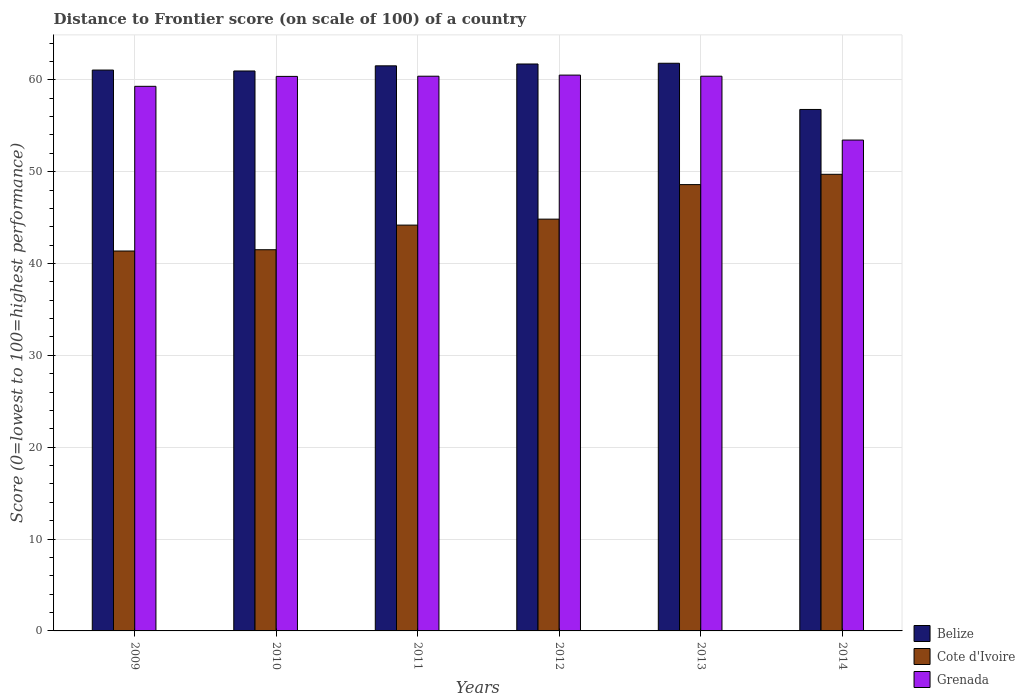How many different coloured bars are there?
Provide a succinct answer. 3. How many groups of bars are there?
Ensure brevity in your answer.  6. How many bars are there on the 3rd tick from the left?
Your answer should be compact. 3. What is the label of the 1st group of bars from the left?
Your answer should be very brief. 2009. In how many cases, is the number of bars for a given year not equal to the number of legend labels?
Provide a succinct answer. 0. What is the distance to frontier score of in Cote d'Ivoire in 2009?
Your answer should be very brief. 41.36. Across all years, what is the maximum distance to frontier score of in Belize?
Offer a very short reply. 61.8. Across all years, what is the minimum distance to frontier score of in Belize?
Your response must be concise. 56.77. In which year was the distance to frontier score of in Grenada maximum?
Your answer should be compact. 2012. In which year was the distance to frontier score of in Grenada minimum?
Give a very brief answer. 2014. What is the total distance to frontier score of in Cote d'Ivoire in the graph?
Your answer should be very brief. 270.17. What is the difference between the distance to frontier score of in Belize in 2012 and that in 2013?
Your response must be concise. -0.08. What is the difference between the distance to frontier score of in Grenada in 2014 and the distance to frontier score of in Belize in 2012?
Keep it short and to the point. -8.28. What is the average distance to frontier score of in Cote d'Ivoire per year?
Your response must be concise. 45.03. In the year 2012, what is the difference between the distance to frontier score of in Belize and distance to frontier score of in Cote d'Ivoire?
Ensure brevity in your answer.  16.89. What is the ratio of the distance to frontier score of in Cote d'Ivoire in 2009 to that in 2013?
Offer a very short reply. 0.85. Is the difference between the distance to frontier score of in Belize in 2011 and 2013 greater than the difference between the distance to frontier score of in Cote d'Ivoire in 2011 and 2013?
Ensure brevity in your answer.  Yes. What is the difference between the highest and the second highest distance to frontier score of in Belize?
Make the answer very short. 0.08. What is the difference between the highest and the lowest distance to frontier score of in Cote d'Ivoire?
Keep it short and to the point. 8.35. Is the sum of the distance to frontier score of in Cote d'Ivoire in 2012 and 2014 greater than the maximum distance to frontier score of in Grenada across all years?
Provide a succinct answer. Yes. What does the 3rd bar from the left in 2013 represents?
Your answer should be compact. Grenada. What does the 1st bar from the right in 2013 represents?
Your answer should be very brief. Grenada. Is it the case that in every year, the sum of the distance to frontier score of in Belize and distance to frontier score of in Cote d'Ivoire is greater than the distance to frontier score of in Grenada?
Make the answer very short. Yes. How many years are there in the graph?
Provide a succinct answer. 6. What is the difference between two consecutive major ticks on the Y-axis?
Provide a succinct answer. 10. Does the graph contain any zero values?
Your response must be concise. No. How many legend labels are there?
Keep it short and to the point. 3. What is the title of the graph?
Make the answer very short. Distance to Frontier score (on scale of 100) of a country. What is the label or title of the Y-axis?
Your answer should be compact. Score (0=lowest to 100=highest performance). What is the Score (0=lowest to 100=highest performance) of Belize in 2009?
Make the answer very short. 61.06. What is the Score (0=lowest to 100=highest performance) of Cote d'Ivoire in 2009?
Ensure brevity in your answer.  41.36. What is the Score (0=lowest to 100=highest performance) of Grenada in 2009?
Provide a short and direct response. 59.29. What is the Score (0=lowest to 100=highest performance) of Belize in 2010?
Offer a terse response. 60.96. What is the Score (0=lowest to 100=highest performance) in Cote d'Ivoire in 2010?
Provide a short and direct response. 41.5. What is the Score (0=lowest to 100=highest performance) in Grenada in 2010?
Offer a very short reply. 60.37. What is the Score (0=lowest to 100=highest performance) in Belize in 2011?
Provide a short and direct response. 61.52. What is the Score (0=lowest to 100=highest performance) of Cote d'Ivoire in 2011?
Offer a terse response. 44.18. What is the Score (0=lowest to 100=highest performance) of Grenada in 2011?
Make the answer very short. 60.39. What is the Score (0=lowest to 100=highest performance) in Belize in 2012?
Your response must be concise. 61.72. What is the Score (0=lowest to 100=highest performance) in Cote d'Ivoire in 2012?
Give a very brief answer. 44.83. What is the Score (0=lowest to 100=highest performance) in Grenada in 2012?
Offer a terse response. 60.51. What is the Score (0=lowest to 100=highest performance) in Belize in 2013?
Your answer should be very brief. 61.8. What is the Score (0=lowest to 100=highest performance) in Cote d'Ivoire in 2013?
Your answer should be very brief. 48.59. What is the Score (0=lowest to 100=highest performance) in Grenada in 2013?
Provide a succinct answer. 60.39. What is the Score (0=lowest to 100=highest performance) in Belize in 2014?
Your response must be concise. 56.77. What is the Score (0=lowest to 100=highest performance) of Cote d'Ivoire in 2014?
Provide a short and direct response. 49.71. What is the Score (0=lowest to 100=highest performance) in Grenada in 2014?
Provide a short and direct response. 53.44. Across all years, what is the maximum Score (0=lowest to 100=highest performance) in Belize?
Make the answer very short. 61.8. Across all years, what is the maximum Score (0=lowest to 100=highest performance) of Cote d'Ivoire?
Keep it short and to the point. 49.71. Across all years, what is the maximum Score (0=lowest to 100=highest performance) in Grenada?
Make the answer very short. 60.51. Across all years, what is the minimum Score (0=lowest to 100=highest performance) of Belize?
Give a very brief answer. 56.77. Across all years, what is the minimum Score (0=lowest to 100=highest performance) of Cote d'Ivoire?
Make the answer very short. 41.36. Across all years, what is the minimum Score (0=lowest to 100=highest performance) in Grenada?
Give a very brief answer. 53.44. What is the total Score (0=lowest to 100=highest performance) in Belize in the graph?
Your answer should be compact. 363.83. What is the total Score (0=lowest to 100=highest performance) of Cote d'Ivoire in the graph?
Your answer should be very brief. 270.17. What is the total Score (0=lowest to 100=highest performance) of Grenada in the graph?
Your answer should be compact. 354.39. What is the difference between the Score (0=lowest to 100=highest performance) in Belize in 2009 and that in 2010?
Your answer should be compact. 0.1. What is the difference between the Score (0=lowest to 100=highest performance) in Cote d'Ivoire in 2009 and that in 2010?
Offer a very short reply. -0.14. What is the difference between the Score (0=lowest to 100=highest performance) of Grenada in 2009 and that in 2010?
Give a very brief answer. -1.08. What is the difference between the Score (0=lowest to 100=highest performance) in Belize in 2009 and that in 2011?
Ensure brevity in your answer.  -0.46. What is the difference between the Score (0=lowest to 100=highest performance) of Cote d'Ivoire in 2009 and that in 2011?
Keep it short and to the point. -2.82. What is the difference between the Score (0=lowest to 100=highest performance) of Belize in 2009 and that in 2012?
Offer a very short reply. -0.66. What is the difference between the Score (0=lowest to 100=highest performance) of Cote d'Ivoire in 2009 and that in 2012?
Your answer should be very brief. -3.47. What is the difference between the Score (0=lowest to 100=highest performance) in Grenada in 2009 and that in 2012?
Ensure brevity in your answer.  -1.22. What is the difference between the Score (0=lowest to 100=highest performance) of Belize in 2009 and that in 2013?
Ensure brevity in your answer.  -0.74. What is the difference between the Score (0=lowest to 100=highest performance) in Cote d'Ivoire in 2009 and that in 2013?
Provide a succinct answer. -7.23. What is the difference between the Score (0=lowest to 100=highest performance) of Grenada in 2009 and that in 2013?
Offer a terse response. -1.1. What is the difference between the Score (0=lowest to 100=highest performance) in Belize in 2009 and that in 2014?
Keep it short and to the point. 4.29. What is the difference between the Score (0=lowest to 100=highest performance) of Cote d'Ivoire in 2009 and that in 2014?
Make the answer very short. -8.35. What is the difference between the Score (0=lowest to 100=highest performance) in Grenada in 2009 and that in 2014?
Give a very brief answer. 5.85. What is the difference between the Score (0=lowest to 100=highest performance) in Belize in 2010 and that in 2011?
Provide a succinct answer. -0.56. What is the difference between the Score (0=lowest to 100=highest performance) of Cote d'Ivoire in 2010 and that in 2011?
Offer a very short reply. -2.68. What is the difference between the Score (0=lowest to 100=highest performance) in Grenada in 2010 and that in 2011?
Your answer should be compact. -0.02. What is the difference between the Score (0=lowest to 100=highest performance) of Belize in 2010 and that in 2012?
Provide a short and direct response. -0.76. What is the difference between the Score (0=lowest to 100=highest performance) of Cote d'Ivoire in 2010 and that in 2012?
Your answer should be very brief. -3.33. What is the difference between the Score (0=lowest to 100=highest performance) of Grenada in 2010 and that in 2012?
Make the answer very short. -0.14. What is the difference between the Score (0=lowest to 100=highest performance) in Belize in 2010 and that in 2013?
Offer a terse response. -0.84. What is the difference between the Score (0=lowest to 100=highest performance) in Cote d'Ivoire in 2010 and that in 2013?
Provide a short and direct response. -7.09. What is the difference between the Score (0=lowest to 100=highest performance) in Grenada in 2010 and that in 2013?
Provide a short and direct response. -0.02. What is the difference between the Score (0=lowest to 100=highest performance) of Belize in 2010 and that in 2014?
Ensure brevity in your answer.  4.19. What is the difference between the Score (0=lowest to 100=highest performance) of Cote d'Ivoire in 2010 and that in 2014?
Offer a very short reply. -8.21. What is the difference between the Score (0=lowest to 100=highest performance) of Grenada in 2010 and that in 2014?
Give a very brief answer. 6.93. What is the difference between the Score (0=lowest to 100=highest performance) in Cote d'Ivoire in 2011 and that in 2012?
Keep it short and to the point. -0.65. What is the difference between the Score (0=lowest to 100=highest performance) in Grenada in 2011 and that in 2012?
Provide a succinct answer. -0.12. What is the difference between the Score (0=lowest to 100=highest performance) in Belize in 2011 and that in 2013?
Make the answer very short. -0.28. What is the difference between the Score (0=lowest to 100=highest performance) in Cote d'Ivoire in 2011 and that in 2013?
Offer a terse response. -4.41. What is the difference between the Score (0=lowest to 100=highest performance) of Grenada in 2011 and that in 2013?
Provide a short and direct response. 0. What is the difference between the Score (0=lowest to 100=highest performance) in Belize in 2011 and that in 2014?
Your answer should be compact. 4.75. What is the difference between the Score (0=lowest to 100=highest performance) in Cote d'Ivoire in 2011 and that in 2014?
Provide a succinct answer. -5.53. What is the difference between the Score (0=lowest to 100=highest performance) of Grenada in 2011 and that in 2014?
Keep it short and to the point. 6.95. What is the difference between the Score (0=lowest to 100=highest performance) in Belize in 2012 and that in 2013?
Give a very brief answer. -0.08. What is the difference between the Score (0=lowest to 100=highest performance) of Cote d'Ivoire in 2012 and that in 2013?
Offer a terse response. -3.76. What is the difference between the Score (0=lowest to 100=highest performance) in Grenada in 2012 and that in 2013?
Provide a succinct answer. 0.12. What is the difference between the Score (0=lowest to 100=highest performance) of Belize in 2012 and that in 2014?
Keep it short and to the point. 4.95. What is the difference between the Score (0=lowest to 100=highest performance) of Cote d'Ivoire in 2012 and that in 2014?
Ensure brevity in your answer.  -4.88. What is the difference between the Score (0=lowest to 100=highest performance) of Grenada in 2012 and that in 2014?
Offer a terse response. 7.07. What is the difference between the Score (0=lowest to 100=highest performance) of Belize in 2013 and that in 2014?
Offer a very short reply. 5.03. What is the difference between the Score (0=lowest to 100=highest performance) in Cote d'Ivoire in 2013 and that in 2014?
Provide a short and direct response. -1.12. What is the difference between the Score (0=lowest to 100=highest performance) of Grenada in 2013 and that in 2014?
Ensure brevity in your answer.  6.95. What is the difference between the Score (0=lowest to 100=highest performance) of Belize in 2009 and the Score (0=lowest to 100=highest performance) of Cote d'Ivoire in 2010?
Make the answer very short. 19.56. What is the difference between the Score (0=lowest to 100=highest performance) in Belize in 2009 and the Score (0=lowest to 100=highest performance) in Grenada in 2010?
Provide a succinct answer. 0.69. What is the difference between the Score (0=lowest to 100=highest performance) of Cote d'Ivoire in 2009 and the Score (0=lowest to 100=highest performance) of Grenada in 2010?
Provide a succinct answer. -19.01. What is the difference between the Score (0=lowest to 100=highest performance) of Belize in 2009 and the Score (0=lowest to 100=highest performance) of Cote d'Ivoire in 2011?
Offer a very short reply. 16.88. What is the difference between the Score (0=lowest to 100=highest performance) of Belize in 2009 and the Score (0=lowest to 100=highest performance) of Grenada in 2011?
Your answer should be very brief. 0.67. What is the difference between the Score (0=lowest to 100=highest performance) in Cote d'Ivoire in 2009 and the Score (0=lowest to 100=highest performance) in Grenada in 2011?
Offer a terse response. -19.03. What is the difference between the Score (0=lowest to 100=highest performance) of Belize in 2009 and the Score (0=lowest to 100=highest performance) of Cote d'Ivoire in 2012?
Make the answer very short. 16.23. What is the difference between the Score (0=lowest to 100=highest performance) of Belize in 2009 and the Score (0=lowest to 100=highest performance) of Grenada in 2012?
Keep it short and to the point. 0.55. What is the difference between the Score (0=lowest to 100=highest performance) in Cote d'Ivoire in 2009 and the Score (0=lowest to 100=highest performance) in Grenada in 2012?
Your answer should be very brief. -19.15. What is the difference between the Score (0=lowest to 100=highest performance) of Belize in 2009 and the Score (0=lowest to 100=highest performance) of Cote d'Ivoire in 2013?
Your answer should be compact. 12.47. What is the difference between the Score (0=lowest to 100=highest performance) in Belize in 2009 and the Score (0=lowest to 100=highest performance) in Grenada in 2013?
Give a very brief answer. 0.67. What is the difference between the Score (0=lowest to 100=highest performance) in Cote d'Ivoire in 2009 and the Score (0=lowest to 100=highest performance) in Grenada in 2013?
Give a very brief answer. -19.03. What is the difference between the Score (0=lowest to 100=highest performance) of Belize in 2009 and the Score (0=lowest to 100=highest performance) of Cote d'Ivoire in 2014?
Your answer should be very brief. 11.35. What is the difference between the Score (0=lowest to 100=highest performance) of Belize in 2009 and the Score (0=lowest to 100=highest performance) of Grenada in 2014?
Give a very brief answer. 7.62. What is the difference between the Score (0=lowest to 100=highest performance) in Cote d'Ivoire in 2009 and the Score (0=lowest to 100=highest performance) in Grenada in 2014?
Provide a succinct answer. -12.08. What is the difference between the Score (0=lowest to 100=highest performance) of Belize in 2010 and the Score (0=lowest to 100=highest performance) of Cote d'Ivoire in 2011?
Offer a terse response. 16.78. What is the difference between the Score (0=lowest to 100=highest performance) of Belize in 2010 and the Score (0=lowest to 100=highest performance) of Grenada in 2011?
Your response must be concise. 0.57. What is the difference between the Score (0=lowest to 100=highest performance) in Cote d'Ivoire in 2010 and the Score (0=lowest to 100=highest performance) in Grenada in 2011?
Provide a succinct answer. -18.89. What is the difference between the Score (0=lowest to 100=highest performance) of Belize in 2010 and the Score (0=lowest to 100=highest performance) of Cote d'Ivoire in 2012?
Your answer should be compact. 16.13. What is the difference between the Score (0=lowest to 100=highest performance) of Belize in 2010 and the Score (0=lowest to 100=highest performance) of Grenada in 2012?
Make the answer very short. 0.45. What is the difference between the Score (0=lowest to 100=highest performance) in Cote d'Ivoire in 2010 and the Score (0=lowest to 100=highest performance) in Grenada in 2012?
Your response must be concise. -19.01. What is the difference between the Score (0=lowest to 100=highest performance) in Belize in 2010 and the Score (0=lowest to 100=highest performance) in Cote d'Ivoire in 2013?
Give a very brief answer. 12.37. What is the difference between the Score (0=lowest to 100=highest performance) of Belize in 2010 and the Score (0=lowest to 100=highest performance) of Grenada in 2013?
Provide a succinct answer. 0.57. What is the difference between the Score (0=lowest to 100=highest performance) in Cote d'Ivoire in 2010 and the Score (0=lowest to 100=highest performance) in Grenada in 2013?
Provide a short and direct response. -18.89. What is the difference between the Score (0=lowest to 100=highest performance) of Belize in 2010 and the Score (0=lowest to 100=highest performance) of Cote d'Ivoire in 2014?
Keep it short and to the point. 11.25. What is the difference between the Score (0=lowest to 100=highest performance) in Belize in 2010 and the Score (0=lowest to 100=highest performance) in Grenada in 2014?
Make the answer very short. 7.52. What is the difference between the Score (0=lowest to 100=highest performance) in Cote d'Ivoire in 2010 and the Score (0=lowest to 100=highest performance) in Grenada in 2014?
Your answer should be very brief. -11.94. What is the difference between the Score (0=lowest to 100=highest performance) of Belize in 2011 and the Score (0=lowest to 100=highest performance) of Cote d'Ivoire in 2012?
Make the answer very short. 16.69. What is the difference between the Score (0=lowest to 100=highest performance) of Belize in 2011 and the Score (0=lowest to 100=highest performance) of Grenada in 2012?
Your answer should be compact. 1.01. What is the difference between the Score (0=lowest to 100=highest performance) of Cote d'Ivoire in 2011 and the Score (0=lowest to 100=highest performance) of Grenada in 2012?
Your response must be concise. -16.33. What is the difference between the Score (0=lowest to 100=highest performance) in Belize in 2011 and the Score (0=lowest to 100=highest performance) in Cote d'Ivoire in 2013?
Your answer should be very brief. 12.93. What is the difference between the Score (0=lowest to 100=highest performance) in Belize in 2011 and the Score (0=lowest to 100=highest performance) in Grenada in 2013?
Ensure brevity in your answer.  1.13. What is the difference between the Score (0=lowest to 100=highest performance) of Cote d'Ivoire in 2011 and the Score (0=lowest to 100=highest performance) of Grenada in 2013?
Your answer should be compact. -16.21. What is the difference between the Score (0=lowest to 100=highest performance) of Belize in 2011 and the Score (0=lowest to 100=highest performance) of Cote d'Ivoire in 2014?
Offer a terse response. 11.81. What is the difference between the Score (0=lowest to 100=highest performance) in Belize in 2011 and the Score (0=lowest to 100=highest performance) in Grenada in 2014?
Make the answer very short. 8.08. What is the difference between the Score (0=lowest to 100=highest performance) in Cote d'Ivoire in 2011 and the Score (0=lowest to 100=highest performance) in Grenada in 2014?
Give a very brief answer. -9.26. What is the difference between the Score (0=lowest to 100=highest performance) in Belize in 2012 and the Score (0=lowest to 100=highest performance) in Cote d'Ivoire in 2013?
Provide a short and direct response. 13.13. What is the difference between the Score (0=lowest to 100=highest performance) of Belize in 2012 and the Score (0=lowest to 100=highest performance) of Grenada in 2013?
Offer a very short reply. 1.33. What is the difference between the Score (0=lowest to 100=highest performance) in Cote d'Ivoire in 2012 and the Score (0=lowest to 100=highest performance) in Grenada in 2013?
Your answer should be compact. -15.56. What is the difference between the Score (0=lowest to 100=highest performance) of Belize in 2012 and the Score (0=lowest to 100=highest performance) of Cote d'Ivoire in 2014?
Keep it short and to the point. 12.01. What is the difference between the Score (0=lowest to 100=highest performance) of Belize in 2012 and the Score (0=lowest to 100=highest performance) of Grenada in 2014?
Offer a very short reply. 8.28. What is the difference between the Score (0=lowest to 100=highest performance) in Cote d'Ivoire in 2012 and the Score (0=lowest to 100=highest performance) in Grenada in 2014?
Ensure brevity in your answer.  -8.61. What is the difference between the Score (0=lowest to 100=highest performance) of Belize in 2013 and the Score (0=lowest to 100=highest performance) of Cote d'Ivoire in 2014?
Your response must be concise. 12.09. What is the difference between the Score (0=lowest to 100=highest performance) in Belize in 2013 and the Score (0=lowest to 100=highest performance) in Grenada in 2014?
Keep it short and to the point. 8.36. What is the difference between the Score (0=lowest to 100=highest performance) in Cote d'Ivoire in 2013 and the Score (0=lowest to 100=highest performance) in Grenada in 2014?
Keep it short and to the point. -4.85. What is the average Score (0=lowest to 100=highest performance) of Belize per year?
Provide a succinct answer. 60.64. What is the average Score (0=lowest to 100=highest performance) of Cote d'Ivoire per year?
Give a very brief answer. 45.03. What is the average Score (0=lowest to 100=highest performance) of Grenada per year?
Your answer should be very brief. 59.06. In the year 2009, what is the difference between the Score (0=lowest to 100=highest performance) of Belize and Score (0=lowest to 100=highest performance) of Cote d'Ivoire?
Give a very brief answer. 19.7. In the year 2009, what is the difference between the Score (0=lowest to 100=highest performance) of Belize and Score (0=lowest to 100=highest performance) of Grenada?
Provide a succinct answer. 1.77. In the year 2009, what is the difference between the Score (0=lowest to 100=highest performance) in Cote d'Ivoire and Score (0=lowest to 100=highest performance) in Grenada?
Provide a short and direct response. -17.93. In the year 2010, what is the difference between the Score (0=lowest to 100=highest performance) of Belize and Score (0=lowest to 100=highest performance) of Cote d'Ivoire?
Provide a succinct answer. 19.46. In the year 2010, what is the difference between the Score (0=lowest to 100=highest performance) of Belize and Score (0=lowest to 100=highest performance) of Grenada?
Your response must be concise. 0.59. In the year 2010, what is the difference between the Score (0=lowest to 100=highest performance) in Cote d'Ivoire and Score (0=lowest to 100=highest performance) in Grenada?
Provide a succinct answer. -18.87. In the year 2011, what is the difference between the Score (0=lowest to 100=highest performance) in Belize and Score (0=lowest to 100=highest performance) in Cote d'Ivoire?
Provide a short and direct response. 17.34. In the year 2011, what is the difference between the Score (0=lowest to 100=highest performance) in Belize and Score (0=lowest to 100=highest performance) in Grenada?
Offer a very short reply. 1.13. In the year 2011, what is the difference between the Score (0=lowest to 100=highest performance) of Cote d'Ivoire and Score (0=lowest to 100=highest performance) of Grenada?
Your response must be concise. -16.21. In the year 2012, what is the difference between the Score (0=lowest to 100=highest performance) in Belize and Score (0=lowest to 100=highest performance) in Cote d'Ivoire?
Ensure brevity in your answer.  16.89. In the year 2012, what is the difference between the Score (0=lowest to 100=highest performance) in Belize and Score (0=lowest to 100=highest performance) in Grenada?
Your response must be concise. 1.21. In the year 2012, what is the difference between the Score (0=lowest to 100=highest performance) in Cote d'Ivoire and Score (0=lowest to 100=highest performance) in Grenada?
Keep it short and to the point. -15.68. In the year 2013, what is the difference between the Score (0=lowest to 100=highest performance) in Belize and Score (0=lowest to 100=highest performance) in Cote d'Ivoire?
Provide a short and direct response. 13.21. In the year 2013, what is the difference between the Score (0=lowest to 100=highest performance) in Belize and Score (0=lowest to 100=highest performance) in Grenada?
Your answer should be very brief. 1.41. In the year 2014, what is the difference between the Score (0=lowest to 100=highest performance) of Belize and Score (0=lowest to 100=highest performance) of Cote d'Ivoire?
Offer a very short reply. 7.06. In the year 2014, what is the difference between the Score (0=lowest to 100=highest performance) in Belize and Score (0=lowest to 100=highest performance) in Grenada?
Your answer should be very brief. 3.33. In the year 2014, what is the difference between the Score (0=lowest to 100=highest performance) of Cote d'Ivoire and Score (0=lowest to 100=highest performance) of Grenada?
Offer a terse response. -3.73. What is the ratio of the Score (0=lowest to 100=highest performance) in Belize in 2009 to that in 2010?
Offer a terse response. 1. What is the ratio of the Score (0=lowest to 100=highest performance) of Grenada in 2009 to that in 2010?
Give a very brief answer. 0.98. What is the ratio of the Score (0=lowest to 100=highest performance) of Cote d'Ivoire in 2009 to that in 2011?
Make the answer very short. 0.94. What is the ratio of the Score (0=lowest to 100=highest performance) in Grenada in 2009 to that in 2011?
Keep it short and to the point. 0.98. What is the ratio of the Score (0=lowest to 100=highest performance) in Belize in 2009 to that in 2012?
Provide a succinct answer. 0.99. What is the ratio of the Score (0=lowest to 100=highest performance) in Cote d'Ivoire in 2009 to that in 2012?
Make the answer very short. 0.92. What is the ratio of the Score (0=lowest to 100=highest performance) in Grenada in 2009 to that in 2012?
Make the answer very short. 0.98. What is the ratio of the Score (0=lowest to 100=highest performance) in Cote d'Ivoire in 2009 to that in 2013?
Ensure brevity in your answer.  0.85. What is the ratio of the Score (0=lowest to 100=highest performance) of Grenada in 2009 to that in 2013?
Ensure brevity in your answer.  0.98. What is the ratio of the Score (0=lowest to 100=highest performance) of Belize in 2009 to that in 2014?
Your response must be concise. 1.08. What is the ratio of the Score (0=lowest to 100=highest performance) of Cote d'Ivoire in 2009 to that in 2014?
Offer a terse response. 0.83. What is the ratio of the Score (0=lowest to 100=highest performance) in Grenada in 2009 to that in 2014?
Your response must be concise. 1.11. What is the ratio of the Score (0=lowest to 100=highest performance) of Belize in 2010 to that in 2011?
Make the answer very short. 0.99. What is the ratio of the Score (0=lowest to 100=highest performance) of Cote d'Ivoire in 2010 to that in 2011?
Offer a terse response. 0.94. What is the ratio of the Score (0=lowest to 100=highest performance) in Grenada in 2010 to that in 2011?
Make the answer very short. 1. What is the ratio of the Score (0=lowest to 100=highest performance) in Cote d'Ivoire in 2010 to that in 2012?
Your answer should be very brief. 0.93. What is the ratio of the Score (0=lowest to 100=highest performance) in Belize in 2010 to that in 2013?
Ensure brevity in your answer.  0.99. What is the ratio of the Score (0=lowest to 100=highest performance) of Cote d'Ivoire in 2010 to that in 2013?
Offer a terse response. 0.85. What is the ratio of the Score (0=lowest to 100=highest performance) of Grenada in 2010 to that in 2013?
Offer a very short reply. 1. What is the ratio of the Score (0=lowest to 100=highest performance) of Belize in 2010 to that in 2014?
Your answer should be very brief. 1.07. What is the ratio of the Score (0=lowest to 100=highest performance) in Cote d'Ivoire in 2010 to that in 2014?
Provide a succinct answer. 0.83. What is the ratio of the Score (0=lowest to 100=highest performance) in Grenada in 2010 to that in 2014?
Give a very brief answer. 1.13. What is the ratio of the Score (0=lowest to 100=highest performance) in Cote d'Ivoire in 2011 to that in 2012?
Offer a terse response. 0.99. What is the ratio of the Score (0=lowest to 100=highest performance) of Belize in 2011 to that in 2013?
Your answer should be compact. 1. What is the ratio of the Score (0=lowest to 100=highest performance) of Cote d'Ivoire in 2011 to that in 2013?
Offer a very short reply. 0.91. What is the ratio of the Score (0=lowest to 100=highest performance) of Belize in 2011 to that in 2014?
Keep it short and to the point. 1.08. What is the ratio of the Score (0=lowest to 100=highest performance) in Cote d'Ivoire in 2011 to that in 2014?
Ensure brevity in your answer.  0.89. What is the ratio of the Score (0=lowest to 100=highest performance) of Grenada in 2011 to that in 2014?
Ensure brevity in your answer.  1.13. What is the ratio of the Score (0=lowest to 100=highest performance) in Belize in 2012 to that in 2013?
Give a very brief answer. 1. What is the ratio of the Score (0=lowest to 100=highest performance) of Cote d'Ivoire in 2012 to that in 2013?
Your response must be concise. 0.92. What is the ratio of the Score (0=lowest to 100=highest performance) in Grenada in 2012 to that in 2013?
Provide a succinct answer. 1. What is the ratio of the Score (0=lowest to 100=highest performance) in Belize in 2012 to that in 2014?
Your answer should be very brief. 1.09. What is the ratio of the Score (0=lowest to 100=highest performance) of Cote d'Ivoire in 2012 to that in 2014?
Provide a succinct answer. 0.9. What is the ratio of the Score (0=lowest to 100=highest performance) in Grenada in 2012 to that in 2014?
Make the answer very short. 1.13. What is the ratio of the Score (0=lowest to 100=highest performance) in Belize in 2013 to that in 2014?
Provide a short and direct response. 1.09. What is the ratio of the Score (0=lowest to 100=highest performance) in Cote d'Ivoire in 2013 to that in 2014?
Make the answer very short. 0.98. What is the ratio of the Score (0=lowest to 100=highest performance) of Grenada in 2013 to that in 2014?
Your answer should be compact. 1.13. What is the difference between the highest and the second highest Score (0=lowest to 100=highest performance) of Cote d'Ivoire?
Keep it short and to the point. 1.12. What is the difference between the highest and the second highest Score (0=lowest to 100=highest performance) of Grenada?
Offer a very short reply. 0.12. What is the difference between the highest and the lowest Score (0=lowest to 100=highest performance) of Belize?
Provide a short and direct response. 5.03. What is the difference between the highest and the lowest Score (0=lowest to 100=highest performance) in Cote d'Ivoire?
Provide a succinct answer. 8.35. What is the difference between the highest and the lowest Score (0=lowest to 100=highest performance) of Grenada?
Offer a very short reply. 7.07. 